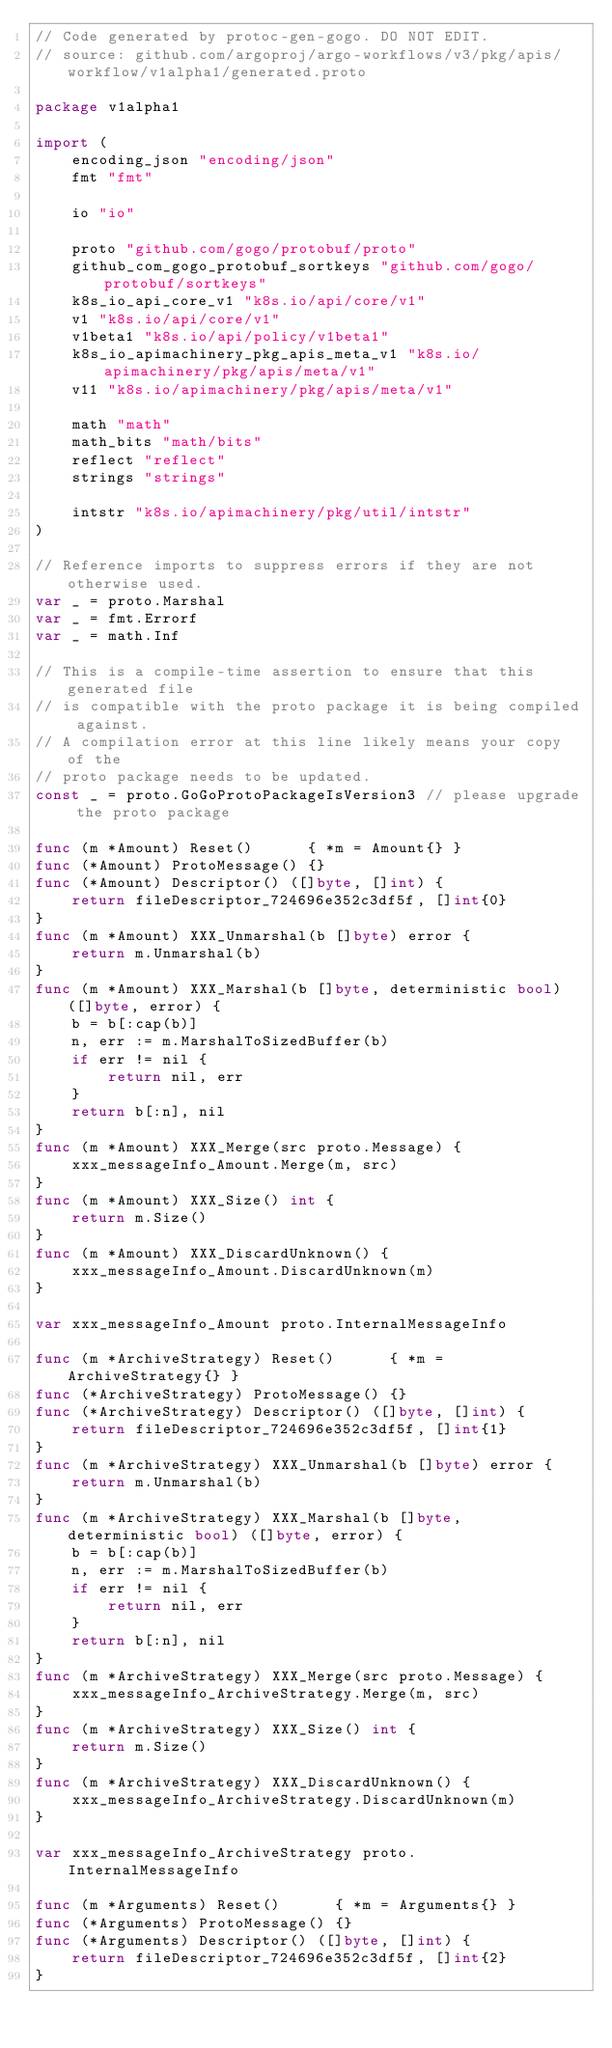<code> <loc_0><loc_0><loc_500><loc_500><_Go_>// Code generated by protoc-gen-gogo. DO NOT EDIT.
// source: github.com/argoproj/argo-workflows/v3/pkg/apis/workflow/v1alpha1/generated.proto

package v1alpha1

import (
	encoding_json "encoding/json"
	fmt "fmt"

	io "io"

	proto "github.com/gogo/protobuf/proto"
	github_com_gogo_protobuf_sortkeys "github.com/gogo/protobuf/sortkeys"
	k8s_io_api_core_v1 "k8s.io/api/core/v1"
	v1 "k8s.io/api/core/v1"
	v1beta1 "k8s.io/api/policy/v1beta1"
	k8s_io_apimachinery_pkg_apis_meta_v1 "k8s.io/apimachinery/pkg/apis/meta/v1"
	v11 "k8s.io/apimachinery/pkg/apis/meta/v1"

	math "math"
	math_bits "math/bits"
	reflect "reflect"
	strings "strings"

	intstr "k8s.io/apimachinery/pkg/util/intstr"
)

// Reference imports to suppress errors if they are not otherwise used.
var _ = proto.Marshal
var _ = fmt.Errorf
var _ = math.Inf

// This is a compile-time assertion to ensure that this generated file
// is compatible with the proto package it is being compiled against.
// A compilation error at this line likely means your copy of the
// proto package needs to be updated.
const _ = proto.GoGoProtoPackageIsVersion3 // please upgrade the proto package

func (m *Amount) Reset()      { *m = Amount{} }
func (*Amount) ProtoMessage() {}
func (*Amount) Descriptor() ([]byte, []int) {
	return fileDescriptor_724696e352c3df5f, []int{0}
}
func (m *Amount) XXX_Unmarshal(b []byte) error {
	return m.Unmarshal(b)
}
func (m *Amount) XXX_Marshal(b []byte, deterministic bool) ([]byte, error) {
	b = b[:cap(b)]
	n, err := m.MarshalToSizedBuffer(b)
	if err != nil {
		return nil, err
	}
	return b[:n], nil
}
func (m *Amount) XXX_Merge(src proto.Message) {
	xxx_messageInfo_Amount.Merge(m, src)
}
func (m *Amount) XXX_Size() int {
	return m.Size()
}
func (m *Amount) XXX_DiscardUnknown() {
	xxx_messageInfo_Amount.DiscardUnknown(m)
}

var xxx_messageInfo_Amount proto.InternalMessageInfo

func (m *ArchiveStrategy) Reset()      { *m = ArchiveStrategy{} }
func (*ArchiveStrategy) ProtoMessage() {}
func (*ArchiveStrategy) Descriptor() ([]byte, []int) {
	return fileDescriptor_724696e352c3df5f, []int{1}
}
func (m *ArchiveStrategy) XXX_Unmarshal(b []byte) error {
	return m.Unmarshal(b)
}
func (m *ArchiveStrategy) XXX_Marshal(b []byte, deterministic bool) ([]byte, error) {
	b = b[:cap(b)]
	n, err := m.MarshalToSizedBuffer(b)
	if err != nil {
		return nil, err
	}
	return b[:n], nil
}
func (m *ArchiveStrategy) XXX_Merge(src proto.Message) {
	xxx_messageInfo_ArchiveStrategy.Merge(m, src)
}
func (m *ArchiveStrategy) XXX_Size() int {
	return m.Size()
}
func (m *ArchiveStrategy) XXX_DiscardUnknown() {
	xxx_messageInfo_ArchiveStrategy.DiscardUnknown(m)
}

var xxx_messageInfo_ArchiveStrategy proto.InternalMessageInfo

func (m *Arguments) Reset()      { *m = Arguments{} }
func (*Arguments) ProtoMessage() {}
func (*Arguments) Descriptor() ([]byte, []int) {
	return fileDescriptor_724696e352c3df5f, []int{2}
}</code> 